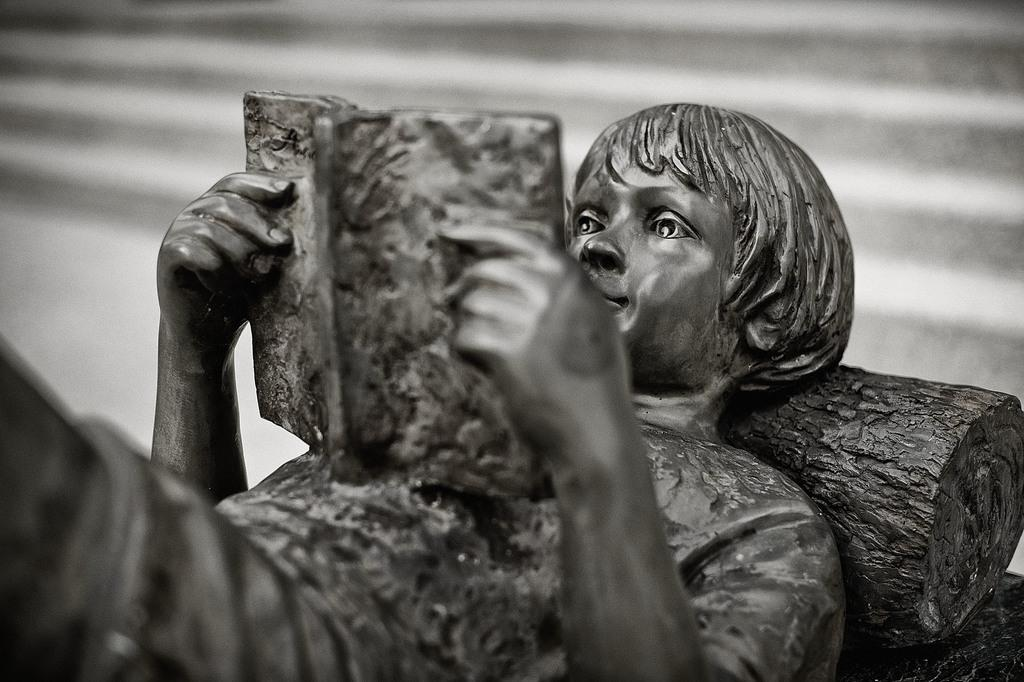What is the main subject in the image? There is a person's stature in the image. What is located behind the person in the image? There is a wall in the image. Can you describe the setting where the image might have been taken? The image is likely taken in a hall. What type of mine can be seen in the image? There is no mine present in the image. What is the cloud's role in the image? There are no clouds present in the image. 